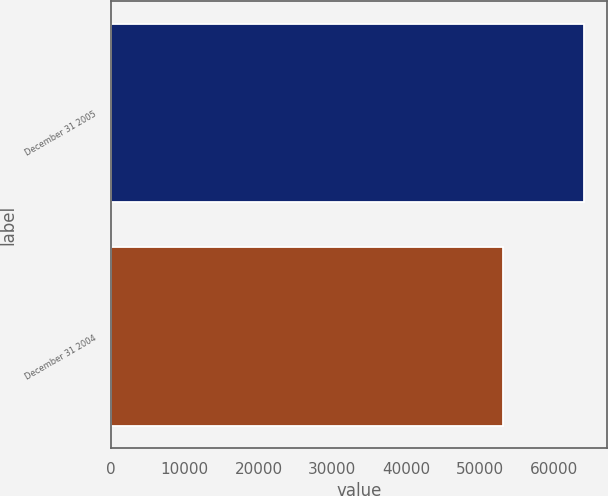Convert chart to OTSL. <chart><loc_0><loc_0><loc_500><loc_500><bar_chart><fcel>December 31 2005<fcel>December 31 2004<nl><fcel>64050<fcel>53083<nl></chart> 